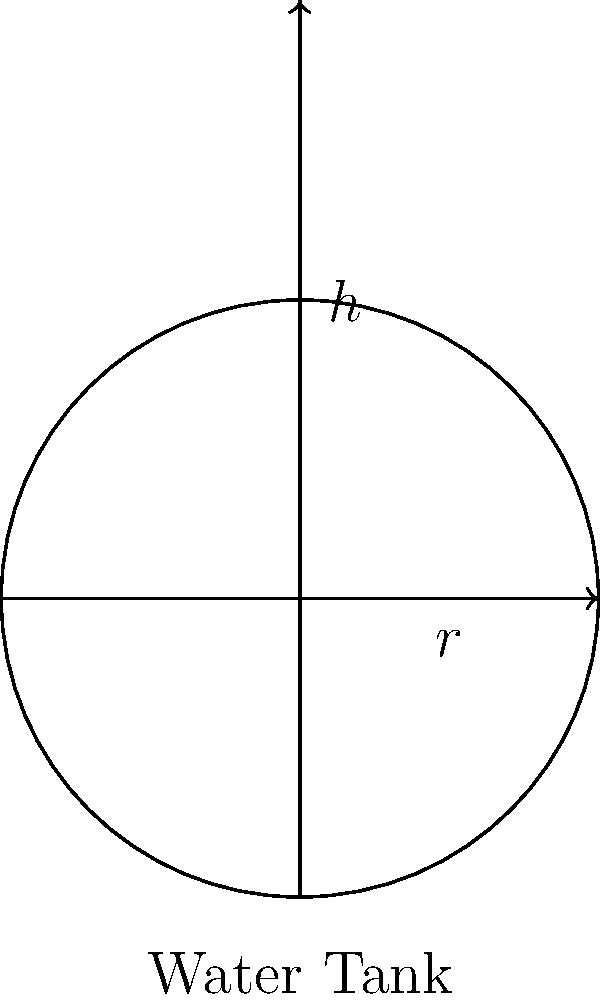As a construction company owner, you're tasked with building a cylindrical water tank for a real estate development project. The architectural plans specify a tank with a radius of 3 meters and a height of 8 meters. What is the volume of this water tank in cubic meters? To find the volume of a cylindrical water tank, we need to use the formula for the volume of a cylinder:

$$V = \pi r^2 h$$

Where:
$V$ = volume
$\pi$ = pi (approximately 3.14159)
$r$ = radius of the base
$h$ = height of the cylinder

Given:
$r = 3$ meters
$h = 8$ meters

Let's substitute these values into the formula:

$$V = \pi (3\,\text{m})^2 (8\,\text{m})$$

$$V = \pi (9\,\text{m}^2) (8\,\text{m})$$

$$V = 72\pi\,\text{m}^3$$

Now, let's calculate the approximate value using $\pi \approx 3.14159$:

$$V \approx 72 \times 3.14159\,\text{m}^3$$

$$V \approx 226.19\,\text{m}^3$$

Therefore, the volume of the cylindrical water tank is approximately 226.19 cubic meters.
Answer: $226.19\,\text{m}^3$ 